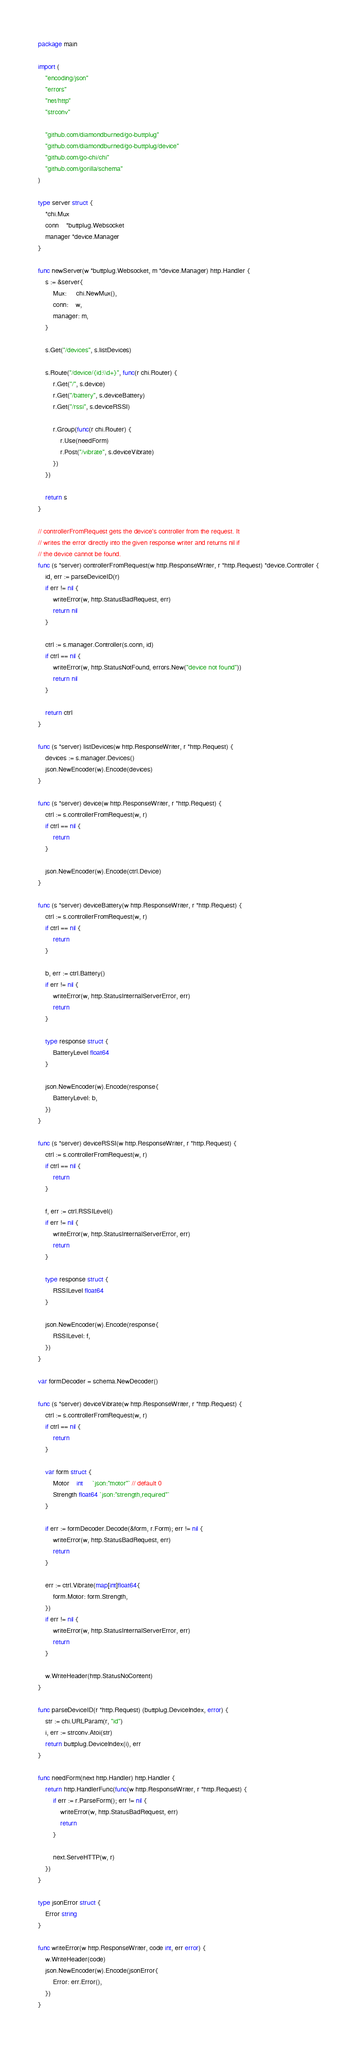<code> <loc_0><loc_0><loc_500><loc_500><_Go_>package main

import (
	"encoding/json"
	"errors"
	"net/http"
	"strconv"

	"github.com/diamondburned/go-buttplug"
	"github.com/diamondburned/go-buttplug/device"
	"github.com/go-chi/chi"
	"github.com/gorilla/schema"
)

type server struct {
	*chi.Mux
	conn    *buttplug.Websocket
	manager *device.Manager
}

func newServer(w *buttplug.Websocket, m *device.Manager) http.Handler {
	s := &server{
		Mux:     chi.NewMux(),
		conn:    w,
		manager: m,
	}

	s.Get("/devices", s.listDevices)

	s.Route("/device/{id:\\d+}", func(r chi.Router) {
		r.Get("/", s.device)
		r.Get("/battery", s.deviceBattery)
		r.Get("/rssi", s.deviceRSSI)

		r.Group(func(r chi.Router) {
			r.Use(needForm)
			r.Post("/vibrate", s.deviceVibrate)
		})
	})

	return s
}

// controllerFromRequest gets the device's controller from the request. It
// writes the error directly into the given response writer and returns nil if
// the device cannot be found.
func (s *server) controllerFromRequest(w http.ResponseWriter, r *http.Request) *device.Controller {
	id, err := parseDeviceID(r)
	if err != nil {
		writeError(w, http.StatusBadRequest, err)
		return nil
	}

	ctrl := s.manager.Controller(s.conn, id)
	if ctrl == nil {
		writeError(w, http.StatusNotFound, errors.New("device not found"))
		return nil
	}

	return ctrl
}

func (s *server) listDevices(w http.ResponseWriter, r *http.Request) {
	devices := s.manager.Devices()
	json.NewEncoder(w).Encode(devices)
}

func (s *server) device(w http.ResponseWriter, r *http.Request) {
	ctrl := s.controllerFromRequest(w, r)
	if ctrl == nil {
		return
	}

	json.NewEncoder(w).Encode(ctrl.Device)
}

func (s *server) deviceBattery(w http.ResponseWriter, r *http.Request) {
	ctrl := s.controllerFromRequest(w, r)
	if ctrl == nil {
		return
	}

	b, err := ctrl.Battery()
	if err != nil {
		writeError(w, http.StatusInternalServerError, err)
		return
	}

	type response struct {
		BatteryLevel float64
	}

	json.NewEncoder(w).Encode(response{
		BatteryLevel: b,
	})
}

func (s *server) deviceRSSI(w http.ResponseWriter, r *http.Request) {
	ctrl := s.controllerFromRequest(w, r)
	if ctrl == nil {
		return
	}

	f, err := ctrl.RSSILevel()
	if err != nil {
		writeError(w, http.StatusInternalServerError, err)
		return
	}

	type response struct {
		RSSILevel float64
	}

	json.NewEncoder(w).Encode(response{
		RSSILevel: f,
	})
}

var formDecoder = schema.NewDecoder()

func (s *server) deviceVibrate(w http.ResponseWriter, r *http.Request) {
	ctrl := s.controllerFromRequest(w, r)
	if ctrl == nil {
		return
	}

	var form struct {
		Motor    int     `json:"motor"` // default 0
		Strength float64 `json:"strength,required"`
	}

	if err := formDecoder.Decode(&form, r.Form); err != nil {
		writeError(w, http.StatusBadRequest, err)
		return
	}

	err := ctrl.Vibrate(map[int]float64{
		form.Motor: form.Strength,
	})
	if err != nil {
		writeError(w, http.StatusInternalServerError, err)
		return
	}

	w.WriteHeader(http.StatusNoContent)
}

func parseDeviceID(r *http.Request) (buttplug.DeviceIndex, error) {
	str := chi.URLParam(r, "id")
	i, err := strconv.Atoi(str)
	return buttplug.DeviceIndex(i), err
}

func needForm(next http.Handler) http.Handler {
	return http.HandlerFunc(func(w http.ResponseWriter, r *http.Request) {
		if err := r.ParseForm(); err != nil {
			writeError(w, http.StatusBadRequest, err)
			return
		}

		next.ServeHTTP(w, r)
	})
}

type jsonError struct {
	Error string
}

func writeError(w http.ResponseWriter, code int, err error) {
	w.WriteHeader(code)
	json.NewEncoder(w).Encode(jsonError{
		Error: err.Error(),
	})
}
</code> 